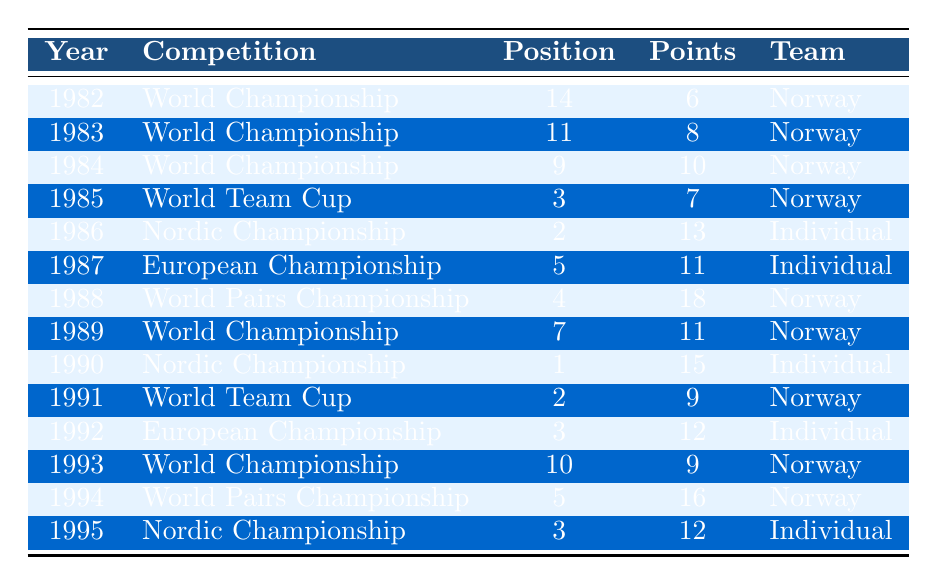What was Tormod Langli's highest position in the World Championship? The table shows Tormod Langli's positions in various competitions. His highest position in the World Championship was 9th place in 1984.
Answer: 9 In which competition did Tormod Langli score the most points? Looking at the points column, the highest score is 18 points, which he achieved in the World Pairs Championship in 1988.
Answer: 18 How many times did Tormod Langli compete in the Nordic Championship? By reviewing the table, Tormod Langli participated in the Nordic Championship three times: in 1986, 1990, and 1995.
Answer: 3 What was Tormod Langli's average position in the World Championship? He competed in the World Championship 6 times, with positions of 14, 11, 9, 7, 10, and 3. The average position is calculated as (14 + 11 + 9 + 7 + 10 + 3) / 6 = 10.
Answer: 10 Did Tormod Langli ever win a competition? The table details his positions in competitions, and there is no instance of him finishing in 1st place in any event.
Answer: No What was Tormod Langli's average points scored across all competitions? He has participated in 15 competitions and the total points scored is 6 + 8 + 10 + 7 + 13 + 11 + 18 + 11 + 15 + 9 + 12 + 9 + 16 + 12 which equals  6 + 8 + 10 + 7 + 13 + 11 + 18 + 11 + 15 + 9 + 12 + 9 + 16 + 12 =  171. The average is 171 / 15 = 11.4.
Answer: 11.4 Which year did Tormod Langli achieve his best position overall? After reviewing the table, Tormod's best standing was 1st in the Nordic Championship in 1990.
Answer: 1st (1990) How many times did Tormod Langli represent the Norwegian team compared to participating as an individual? From the table, he represented Norway in 10 competitions and competed as an individual in 5 events.
Answer: 10 to 5 What was the total number of points earned in World Team Cup events? The World Team Cup results in the table show points of 7 and 9 in 1985 and 1991 respectively. Adding these points gives us 7 + 9 = 16 points total.
Answer: 16 In which competition and year did Tormod Langli place 2nd? The table indicates that Tormod placed 2nd in the Nordic Championship in 1986 and in the World Team Cup in 1991.
Answer: Nordic Championship (1986), World Team Cup (1991) 